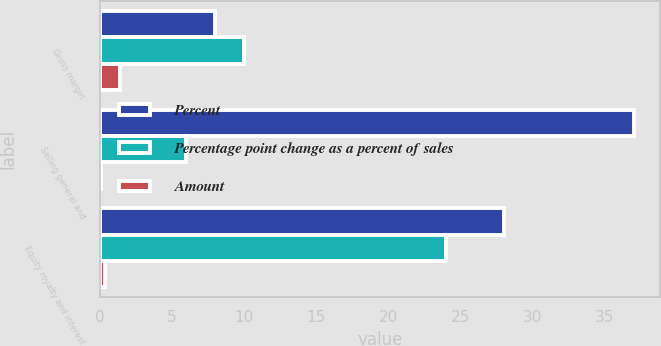<chart> <loc_0><loc_0><loc_500><loc_500><stacked_bar_chart><ecel><fcel>Gross margin<fcel>Selling general and<fcel>Equity royalty and interest<nl><fcel>Percent<fcel>8<fcel>37<fcel>28<nl><fcel>Percentage point change as a percent of sales<fcel>10<fcel>6<fcel>24<nl><fcel>Amount<fcel>1.4<fcel>0.1<fcel>0.4<nl></chart> 